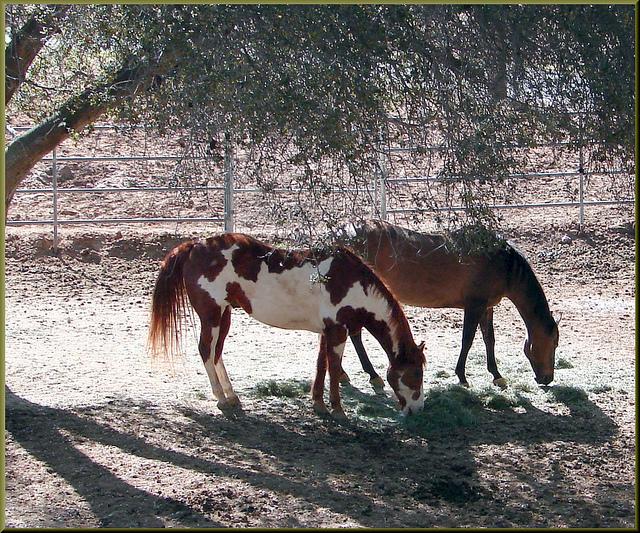What is cast on the ground?
Answer briefly. Shadows. Are the horses in the shade?
Keep it brief. Yes. Are the horses the same color?
Write a very short answer. No. 